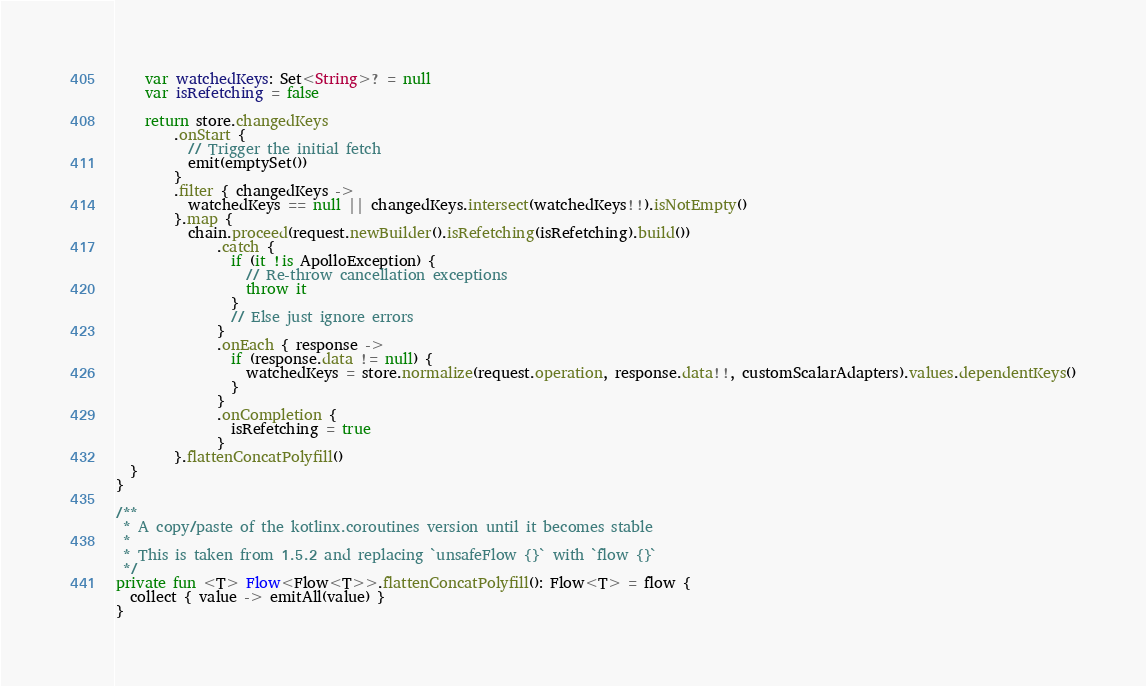<code> <loc_0><loc_0><loc_500><loc_500><_Kotlin_>    var watchedKeys: Set<String>? = null
    var isRefetching = false

    return store.changedKeys
        .onStart {
          // Trigger the initial fetch
          emit(emptySet())
        }
        .filter { changedKeys ->
          watchedKeys == null || changedKeys.intersect(watchedKeys!!).isNotEmpty()
        }.map {
          chain.proceed(request.newBuilder().isRefetching(isRefetching).build())
              .catch {
                if (it !is ApolloException) {
                  // Re-throw cancellation exceptions
                  throw it
                }
                // Else just ignore errors
              }
              .onEach { response ->
                if (response.data != null) {
                  watchedKeys = store.normalize(request.operation, response.data!!, customScalarAdapters).values.dependentKeys()
                }
              }
              .onCompletion {
                isRefetching = true
              }
        }.flattenConcatPolyfill()
  }
}

/**
 * A copy/paste of the kotlinx.coroutines version until it becomes stable
 *
 * This is taken from 1.5.2 and replacing `unsafeFlow {}` with `flow {}`
 */
private fun <T> Flow<Flow<T>>.flattenConcatPolyfill(): Flow<T> = flow {
  collect { value -> emitAll(value) }
}</code> 